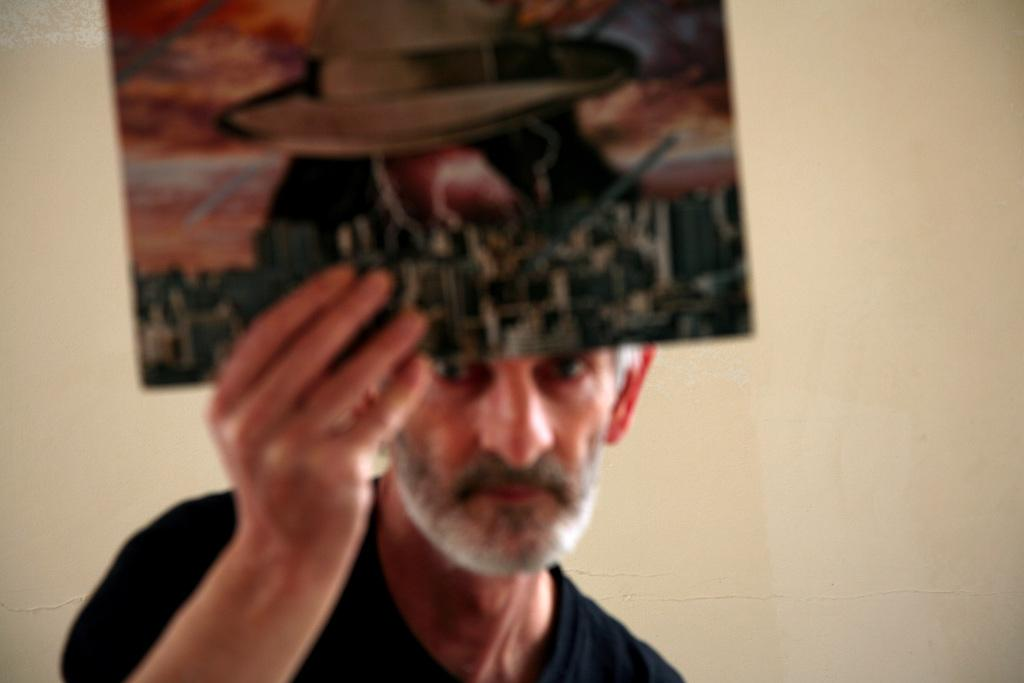Who is the main subject in the image? There is a person in the image. What is the person holding in the image? The person is holding a multi-color board. What is the color of the background in the image? The background of the image is cream-colored. Is the person's sister talking to them at the table in the image? There is no mention of a sister or a table in the image, and the person is holding a multi-color board, not talking to anyone. 